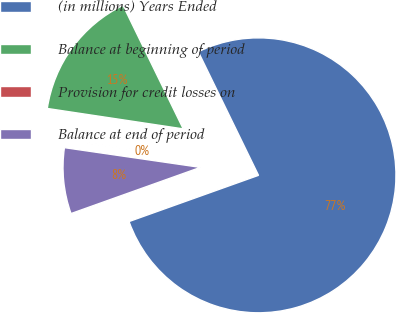Convert chart to OTSL. <chart><loc_0><loc_0><loc_500><loc_500><pie_chart><fcel>(in millions) Years Ended<fcel>Balance at beginning of period<fcel>Provision for credit losses on<fcel>Balance at end of period<nl><fcel>76.76%<fcel>15.41%<fcel>0.08%<fcel>7.75%<nl></chart> 